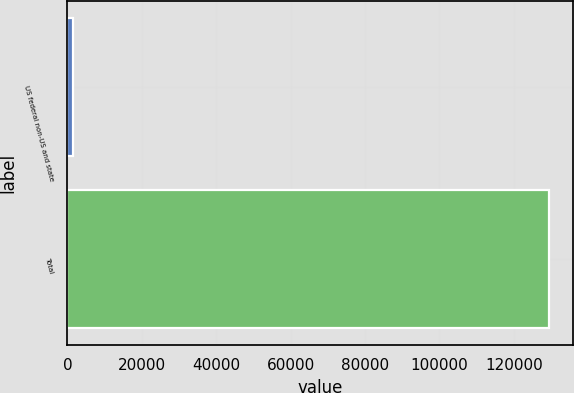Convert chart. <chart><loc_0><loc_0><loc_500><loc_500><bar_chart><fcel>US federal non-US and state<fcel>Total<nl><fcel>1564<fcel>129448<nl></chart> 